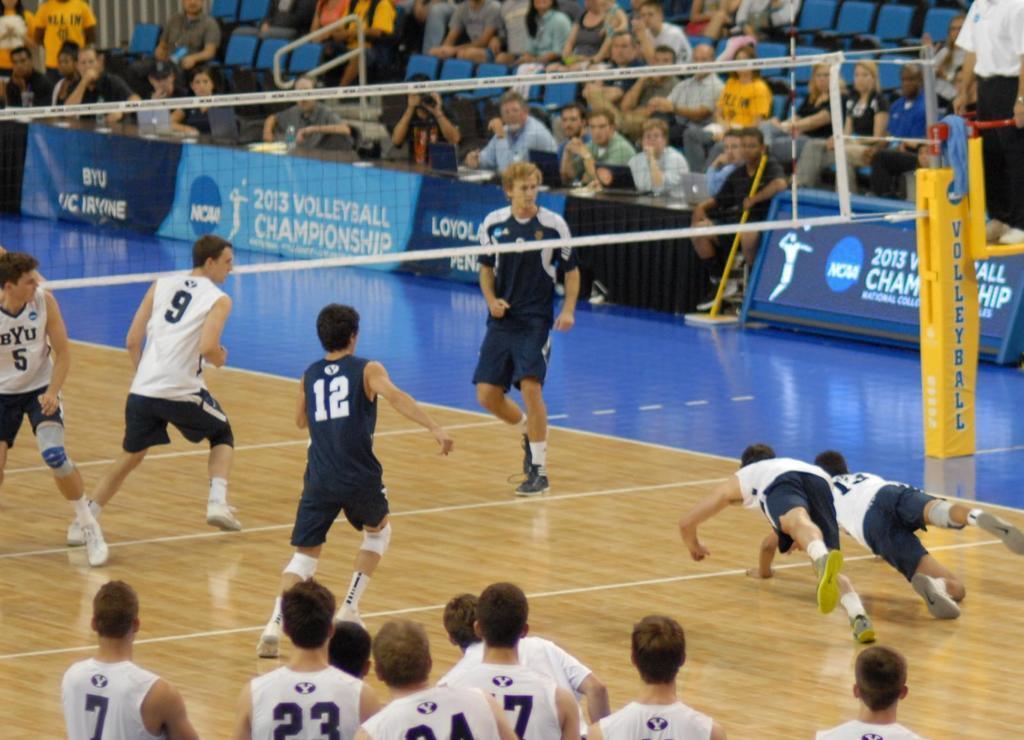Please provide a concise description of this image. In this picture we can see a group of people where some are on the ground and some are sitting on chairs, net, banners. 